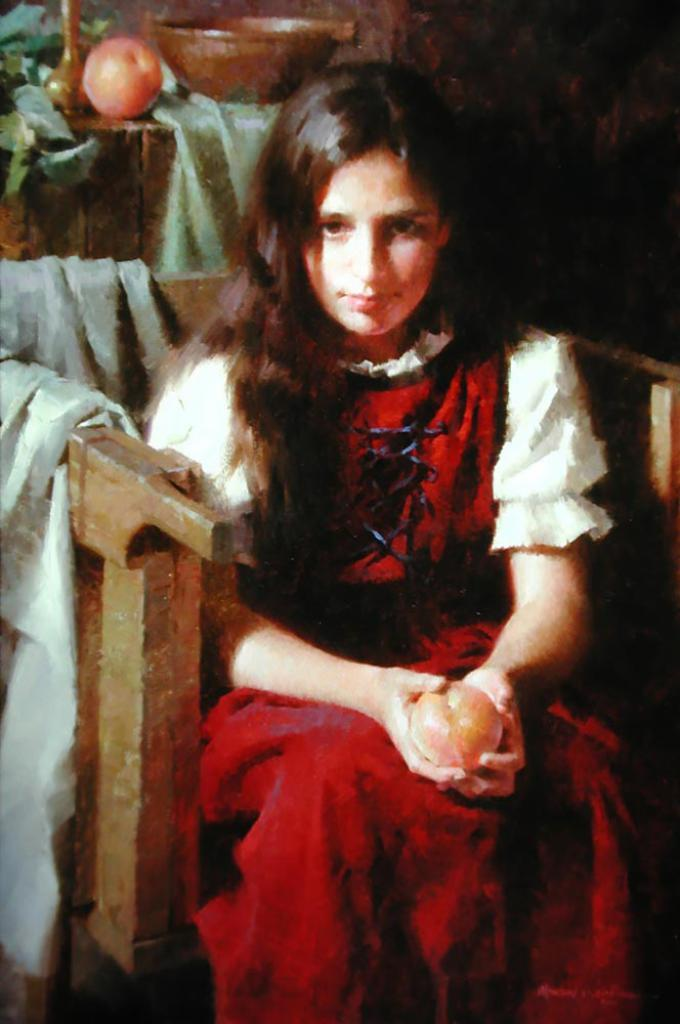What type of artwork is depicted in the image? The image is a painting. Who or what is the main subject of the painting? There is a girl in the painting. What is the girl doing in the painting? The girl is seated on a chair and holding a fruit in her hands. What else can be seen on the table in the painting? There is a fruit and a bowl on the table. What other elements are present in the painting? There are leaves and a cloth on the chair. How many kittens are playing on the seashore in the painting? There are no kittens or seashore present in the painting; it features a girl seated on a chair holding a fruit. 